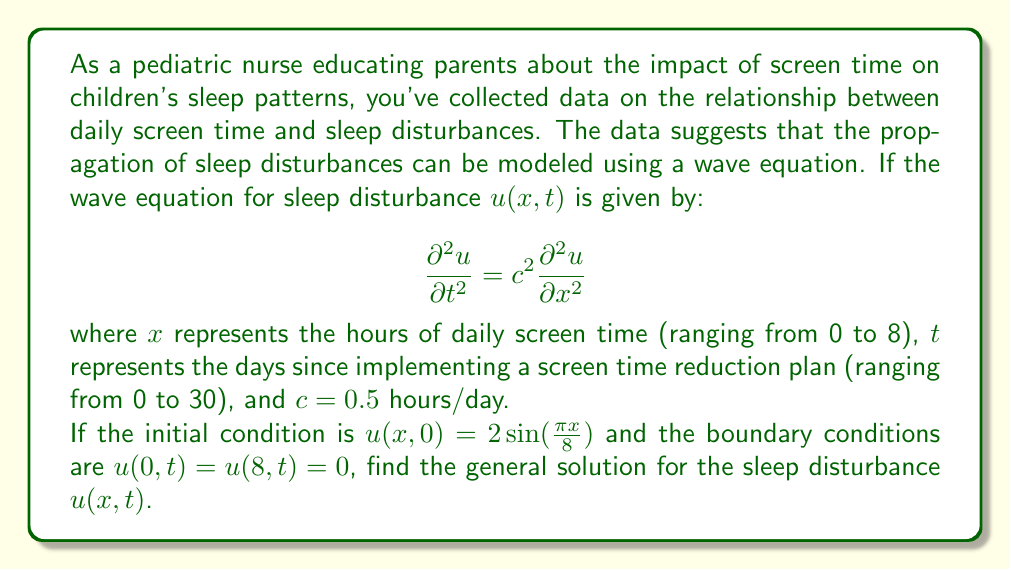Can you answer this question? To solve this wave equation, we'll use the method of separation of variables:

1) Assume $u(x,t) = X(x)T(t)$

2) Substituting this into the wave equation:
   $$X(x)T''(t) = c^2X''(x)T(t)$$

3) Dividing both sides by $X(x)T(t)$:
   $$\frac{T''(t)}{T(t)} = c^2\frac{X''(x)}{X(x)} = -\lambda$$

   where $\lambda$ is a constant.

4) This gives us two ordinary differential equations:
   $$T''(t) + \lambda c^2T(t) = 0$$
   $$X''(x) + \lambda X(x) = 0$$

5) The boundary conditions $u(0,t) = u(8,t) = 0$ imply $X(0) = X(8) = 0$. This, along with the equation for $X(x)$, forms a Sturm-Liouville problem with eigenvalues:
   $$\lambda_n = (\frac{n\pi}{8})^2, n = 1,2,3,...$$

6) The corresponding eigenfunctions are:
   $$X_n(x) = \sin(\frac{n\pi x}{8})$$

7) For $T(t)$, we have:
   $$T_n(t) = A_n\cos(\frac{n\pi c t}{8}) + B_n\sin(\frac{n\pi c t}{8})$$

8) The general solution is:
   $$u(x,t) = \sum_{n=1}^{\infty} [A_n\cos(\frac{n\pi c t}{8}) + B_n\sin(\frac{n\pi c t}{8})]\sin(\frac{n\pi x}{8})$$

9) Using the initial condition $u(x,0) = 2\sin(\frac{\pi x}{8})$, we can determine that $A_1 = 2$ and all other $A_n = 0$. The initial velocity $\frac{\partial u}{\partial t}(x,0) = 0$ implies all $B_n = 0$.

Therefore, the final solution is:
$$u(x,t) = 2\cos(\frac{\pi c t}{8})\sin(\frac{\pi x}{8})$$
Answer: $$u(x,t) = 2\cos(\frac{\pi c t}{8})\sin(\frac{\pi x}{8})$$
where $c = 0.5$ hours/day 